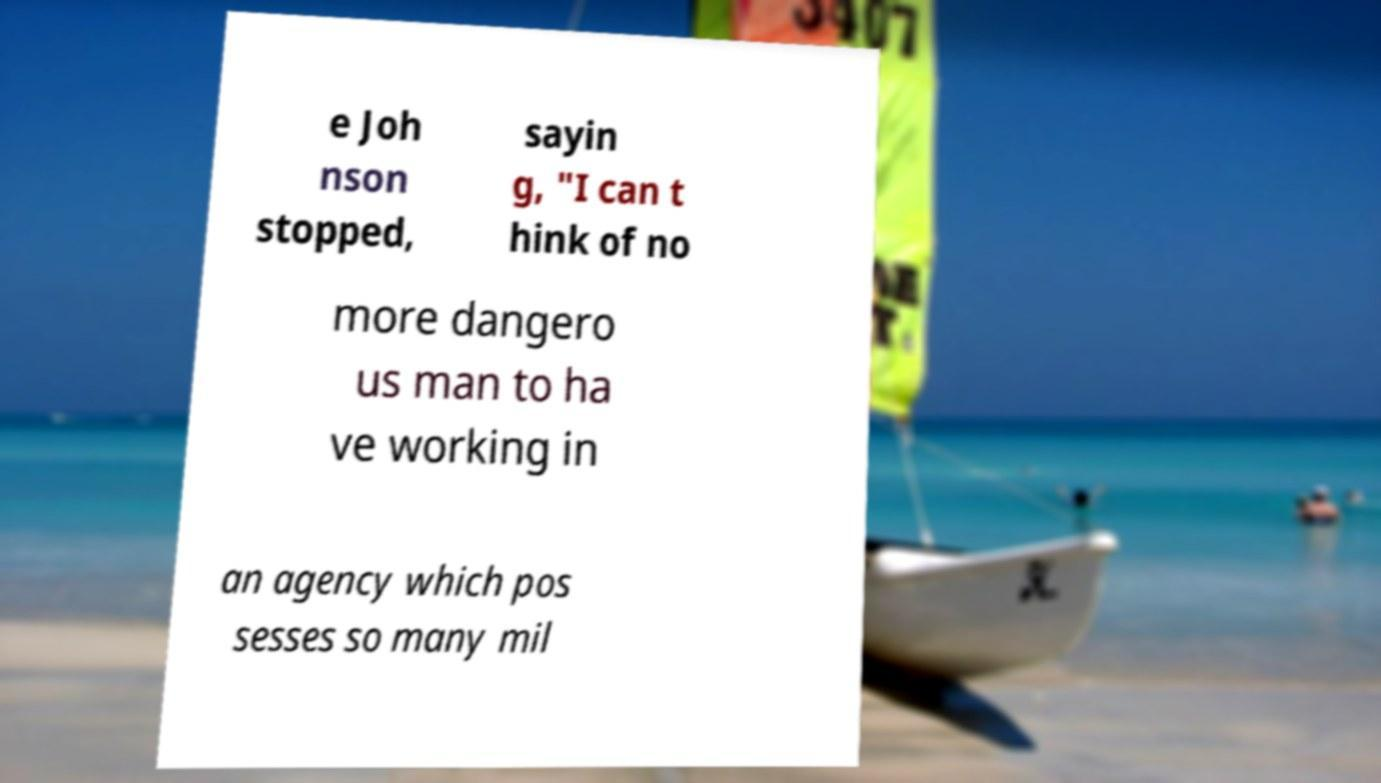I need the written content from this picture converted into text. Can you do that? e Joh nson stopped, sayin g, "I can t hink of no more dangero us man to ha ve working in an agency which pos sesses so many mil 